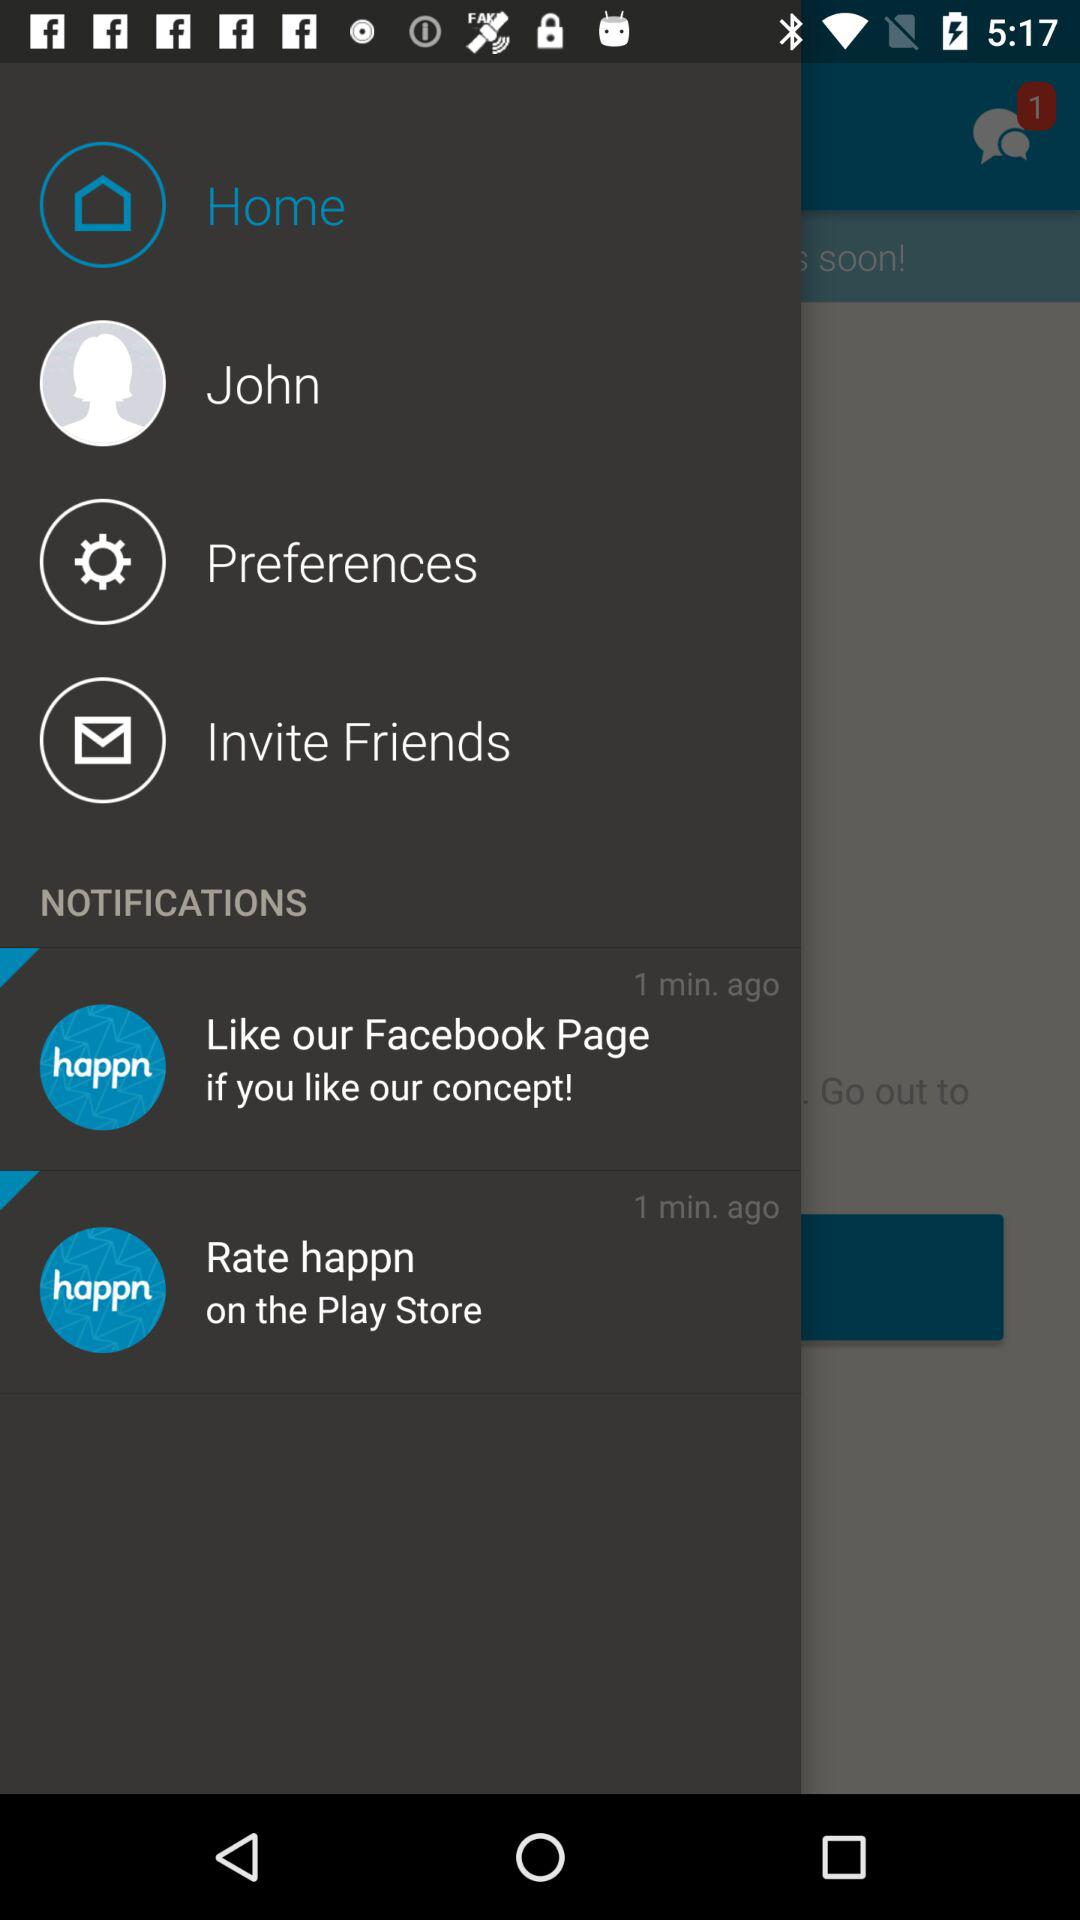What is the name of the user? The name of the user is John. 